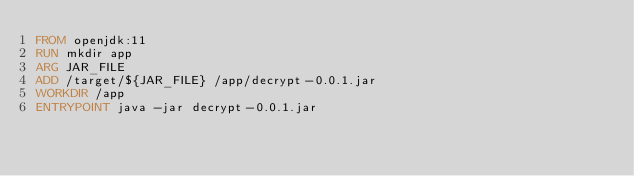Convert code to text. <code><loc_0><loc_0><loc_500><loc_500><_Dockerfile_>FROM openjdk:11
RUN mkdir app
ARG JAR_FILE
ADD /target/${JAR_FILE} /app/decrypt-0.0.1.jar
WORKDIR /app
ENTRYPOINT java -jar decrypt-0.0.1.jar</code> 